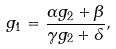Convert formula to latex. <formula><loc_0><loc_0><loc_500><loc_500>g _ { 1 } = \frac { \alpha g _ { 2 } + \beta } { \gamma g _ { 2 } + \delta } ,</formula> 